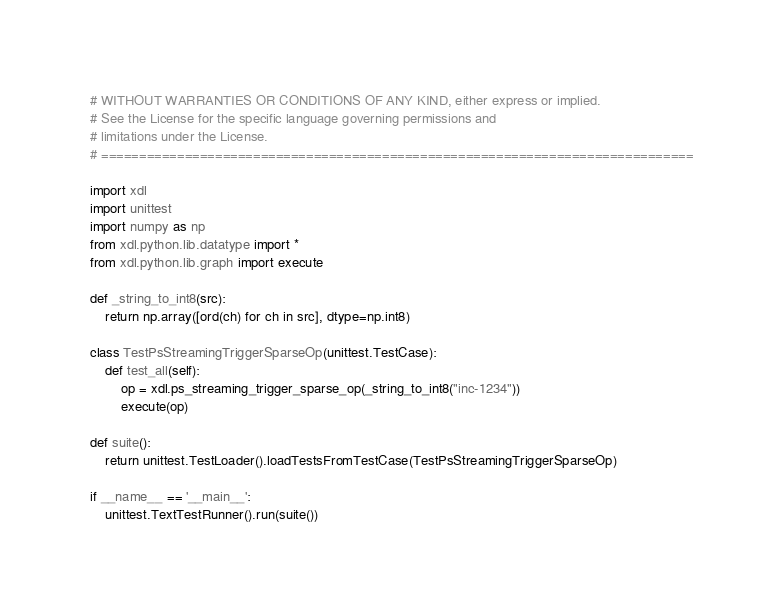<code> <loc_0><loc_0><loc_500><loc_500><_Python_># WITHOUT WARRANTIES OR CONDITIONS OF ANY KIND, either express or implied.
# See the License for the specific language governing permissions and
# limitations under the License.
# ==============================================================================

import xdl
import unittest
import numpy as np
from xdl.python.lib.datatype import *
from xdl.python.lib.graph import execute

def _string_to_int8(src):
    return np.array([ord(ch) for ch in src], dtype=np.int8)

class TestPsStreamingTriggerSparseOp(unittest.TestCase):
    def test_all(self):
        op = xdl.ps_streaming_trigger_sparse_op(_string_to_int8("inc-1234"))
        execute(op)

def suite():
    return unittest.TestLoader().loadTestsFromTestCase(TestPsStreamingTriggerSparseOp)

if __name__ == '__main__':
    unittest.TextTestRunner().run(suite())

</code> 